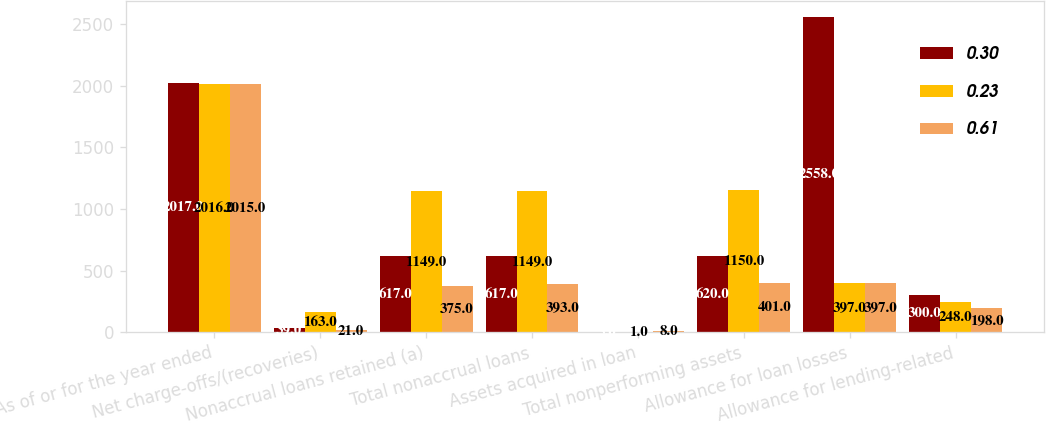<chart> <loc_0><loc_0><loc_500><loc_500><stacked_bar_chart><ecel><fcel>As of or for the year ended<fcel>Net charge-offs/(recoveries)<fcel>Nonaccrual loans retained (a)<fcel>Total nonaccrual loans<fcel>Assets acquired in loan<fcel>Total nonperforming assets<fcel>Allowance for loan losses<fcel>Allowance for lending-related<nl><fcel>0.3<fcel>2017<fcel>39<fcel>617<fcel>617<fcel>3<fcel>620<fcel>2558<fcel>300<nl><fcel>0.23<fcel>2016<fcel>163<fcel>1149<fcel>1149<fcel>1<fcel>1150<fcel>397<fcel>248<nl><fcel>0.61<fcel>2015<fcel>21<fcel>375<fcel>393<fcel>8<fcel>401<fcel>397<fcel>198<nl></chart> 